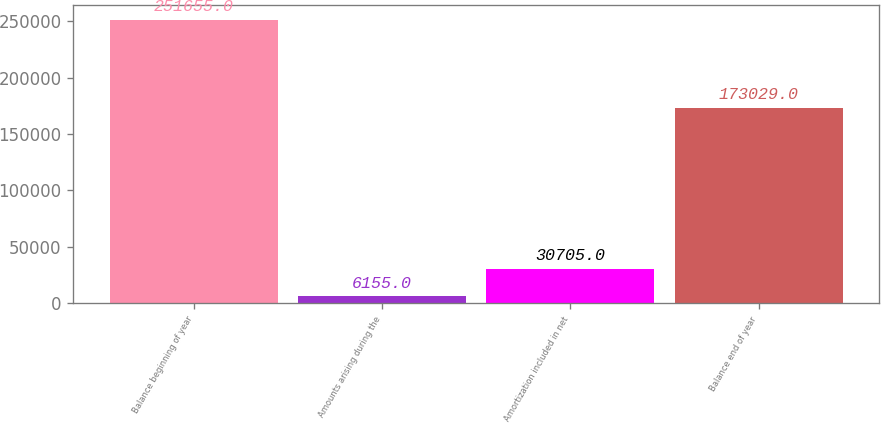<chart> <loc_0><loc_0><loc_500><loc_500><bar_chart><fcel>Balance beginning of year<fcel>Amounts arising during the<fcel>Amortization included in net<fcel>Balance end of year<nl><fcel>251655<fcel>6155<fcel>30705<fcel>173029<nl></chart> 